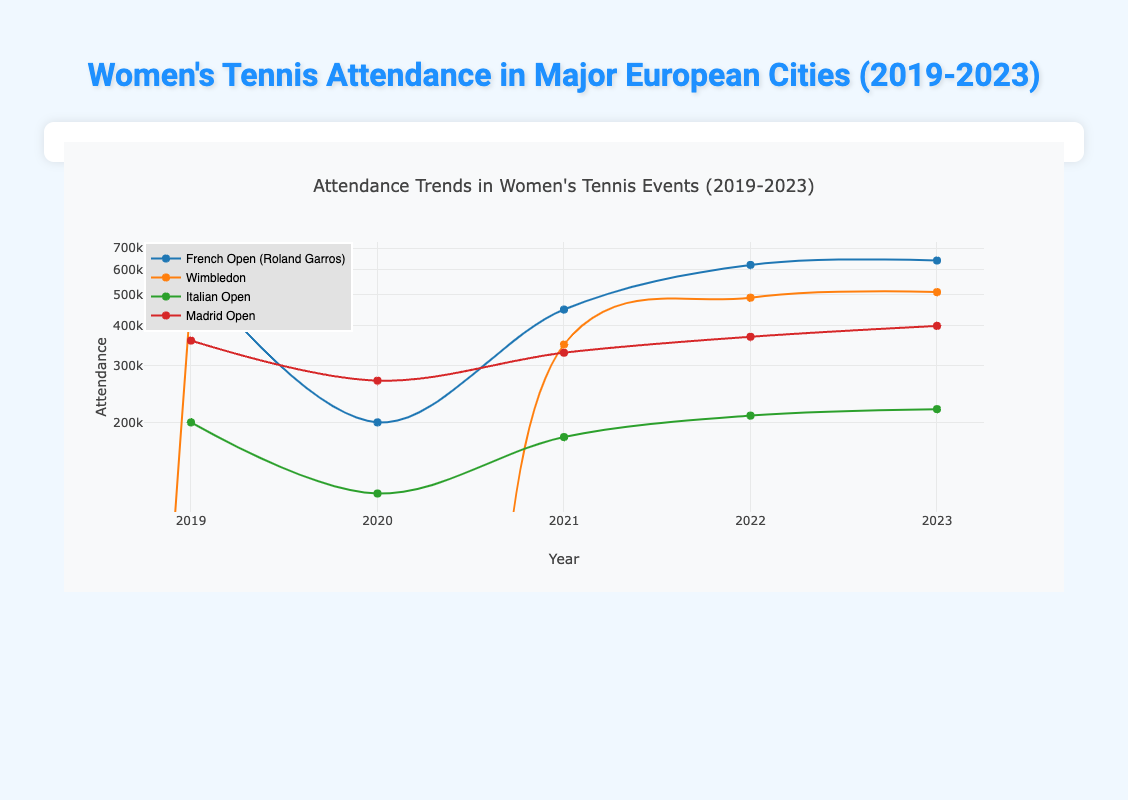What was the attendance at the French Open in 2022? The attendance at the French Open in 2022 is listed in the table under the event "French Open (Roland Garros)" for the year 2022, which shows a value of 620,000.
Answer: 620000 How much did the attendance at Wimbledon change from 2019 to 2023? To find the change, we compare the attendance figures for Wimbledon in 2019 (500,000) and 2023 (510,000). The change is calculated as 510,000 - 500,000 = 10,000.
Answer: 10000 Was the attendance at the Italian Open the same in 2021 and 2022? The attendance for the Italian Open in 2021 was 180,000, while in 2022 it was 210,000. Since these figures are different, the answer is no.
Answer: No What is the total attendance for the Madrid Open over all years reported? We can find the total attendance for the Madrid Open by adding the values from 2019 (360,000), 2020 (270,000), 2021 (330,000), 2022 (370,000), and 2023 (400,000). The sum is calculated as follows: 360,000 + 270,000 + 330,000 + 370,000 + 400,000 = 1,730,000.
Answer: 1730000 In which year did the French Open (Roland Garros) have the highest attendance? By examining the attendance numbers for the French Open across the years (2019: 600,000, 2020: 200,000, 2021: 450,000, 2022: 620,000, 2023: 640,000), we see that the highest attendance was in 2023 with 640,000.
Answer: 2023 How does the attendance at Wimbledon in 2020 compare to its attendance in 2021? The attendance at Wimbledon in 2020 was 0, and in 2021 it was 350,000. The comparison shows a significant increase in attendance from 0 to 350,000 from 2020 to 2021.
Answer: Increased What is the average attendance for the Italian Open over the years reported? The attendance figures for the Italian Open are: 200,000 (2019), 120,000 (2020), 180,000 (2021), 210,000 (2022), and 220,000 (2023). To find the average, we add them up: 200,000 + 120,000 + 180,000 + 210,000 + 220,000 = 1,030,000. Then we divide by the number of years, which is 5, resulting in an average of 206,000.
Answer: 206000 Did more people attend the French Open in 2023 than in the Italian Open in the same year? The attendance for the French Open in 2023 is 640,000, while the attendance for the Italian Open in 2023 is 220,000. Since 640,000 is greater than 220,000, the answer is yes.
Answer: Yes Which event had the lowest attendance in the year 2020? Looking at the attendance for 2020, we see that Wimbledon had an attendance of 0, while other events (French Open: 200,000, Italian Open: 120,000, Madrid Open: 270,000) had higher figures. Therefore, the event with the lowest attendance is Wimbledon.
Answer: Wimbledon 